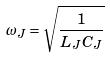Convert formula to latex. <formula><loc_0><loc_0><loc_500><loc_500>\omega _ { J } = \sqrt { \frac { 1 } { L _ { J } C _ { J } } }</formula> 